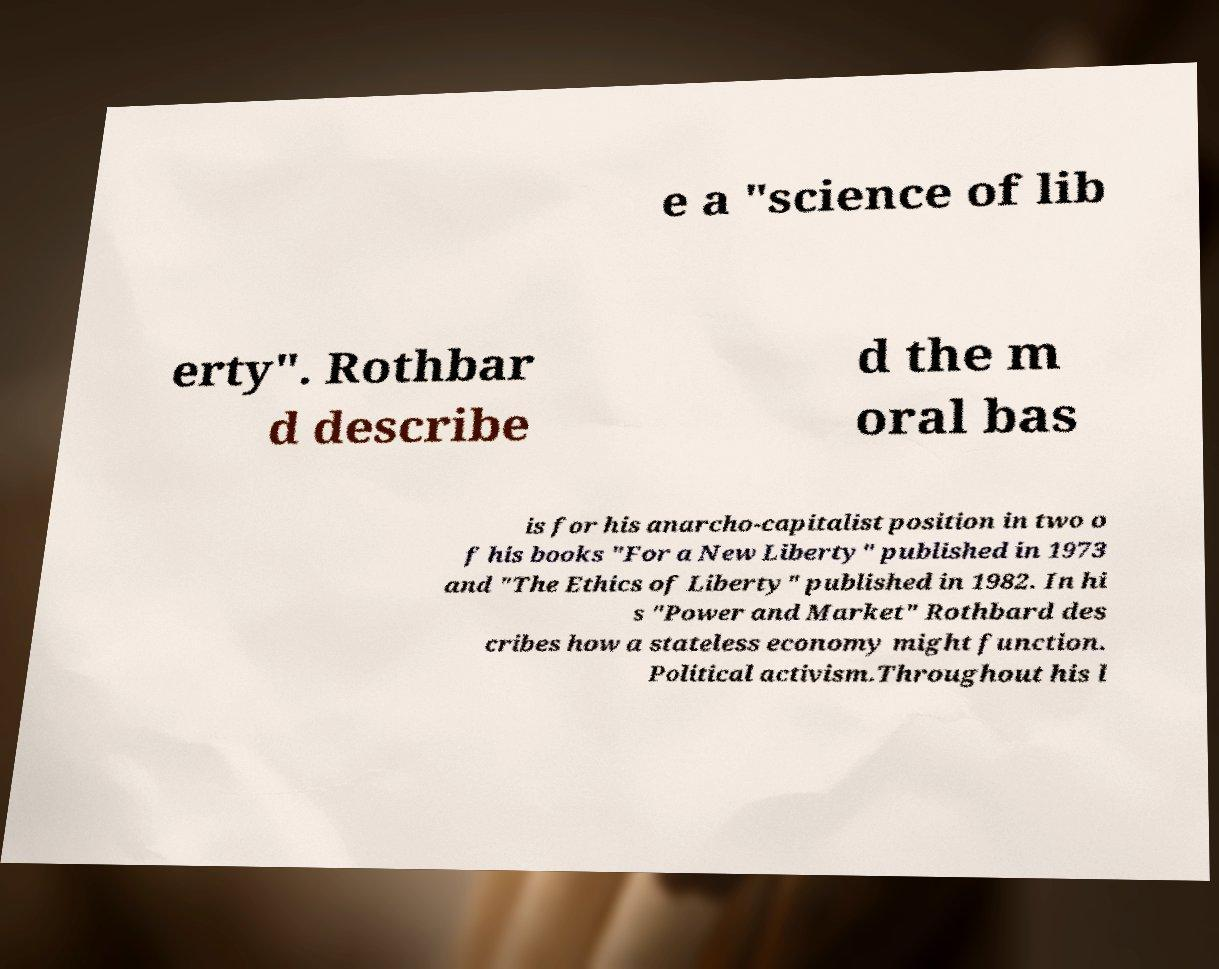Please identify and transcribe the text found in this image. e a "science of lib erty". Rothbar d describe d the m oral bas is for his anarcho-capitalist position in two o f his books "For a New Liberty" published in 1973 and "The Ethics of Liberty" published in 1982. In hi s "Power and Market" Rothbard des cribes how a stateless economy might function. Political activism.Throughout his l 